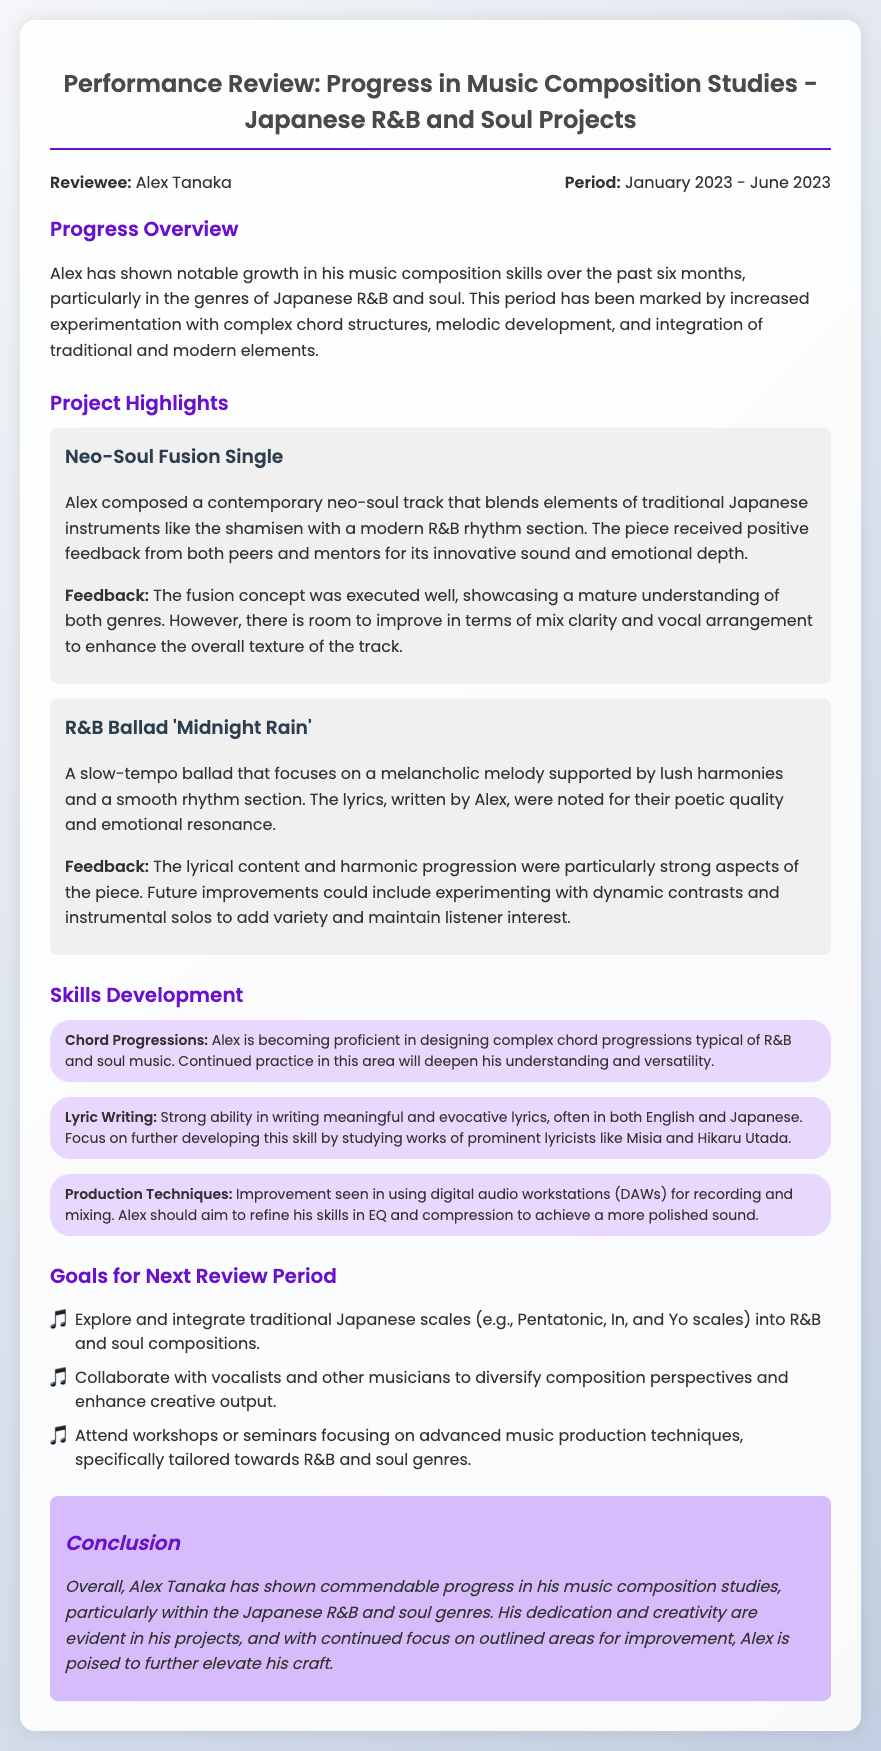What is the reviewee's name? The reviewee's name is stated at the beginning of the document as Alex Tanaka.
Answer: Alex Tanaka What is the review period? The review period is indicated in the header section of the document as January 2023 to June 2023.
Answer: January 2023 - June 2023 What is the title of the first project? The first project title is found under the Project Highlights section, listed as Neo-Soul Fusion Single.
Answer: Neo-Soul Fusion Single What genre does Alex focus on? The document mentions that Alex focuses on Japanese R&B and soul music throughout its sections.
Answer: Japanese R&B and soul What is one area Alex is aiming to improve in his skills? The Skills Development section outlines various skills, one of which is refining EQ and compression techniques for a polished sound.
Answer: EQ and compression techniques What type of collaboration is suggested for Alex's goals? The Goals section specifies collaborating with vocalists and other musicians as a target for enhancing creative output.
Answer: Collaborate with vocalists and other musicians What was one positive feedback aspect of the 'Midnight Rain' project? Feedback for the 'Midnight Rain' project highlighted the lyrical content and harmonic progression as strong elements of the piece.
Answer: Lyrical content and harmonic progression What is a goal Alex plans to explore? Among the goals listed, exploring traditional Japanese scales is one of the highlighted objectives for the next review period.
Answer: Traditional Japanese scales How does the review characterize Alex's overall progress? In the conclusion, Alex's progress is described as commendable, reflecting his dedication and creativity in his studies.
Answer: Commendable 